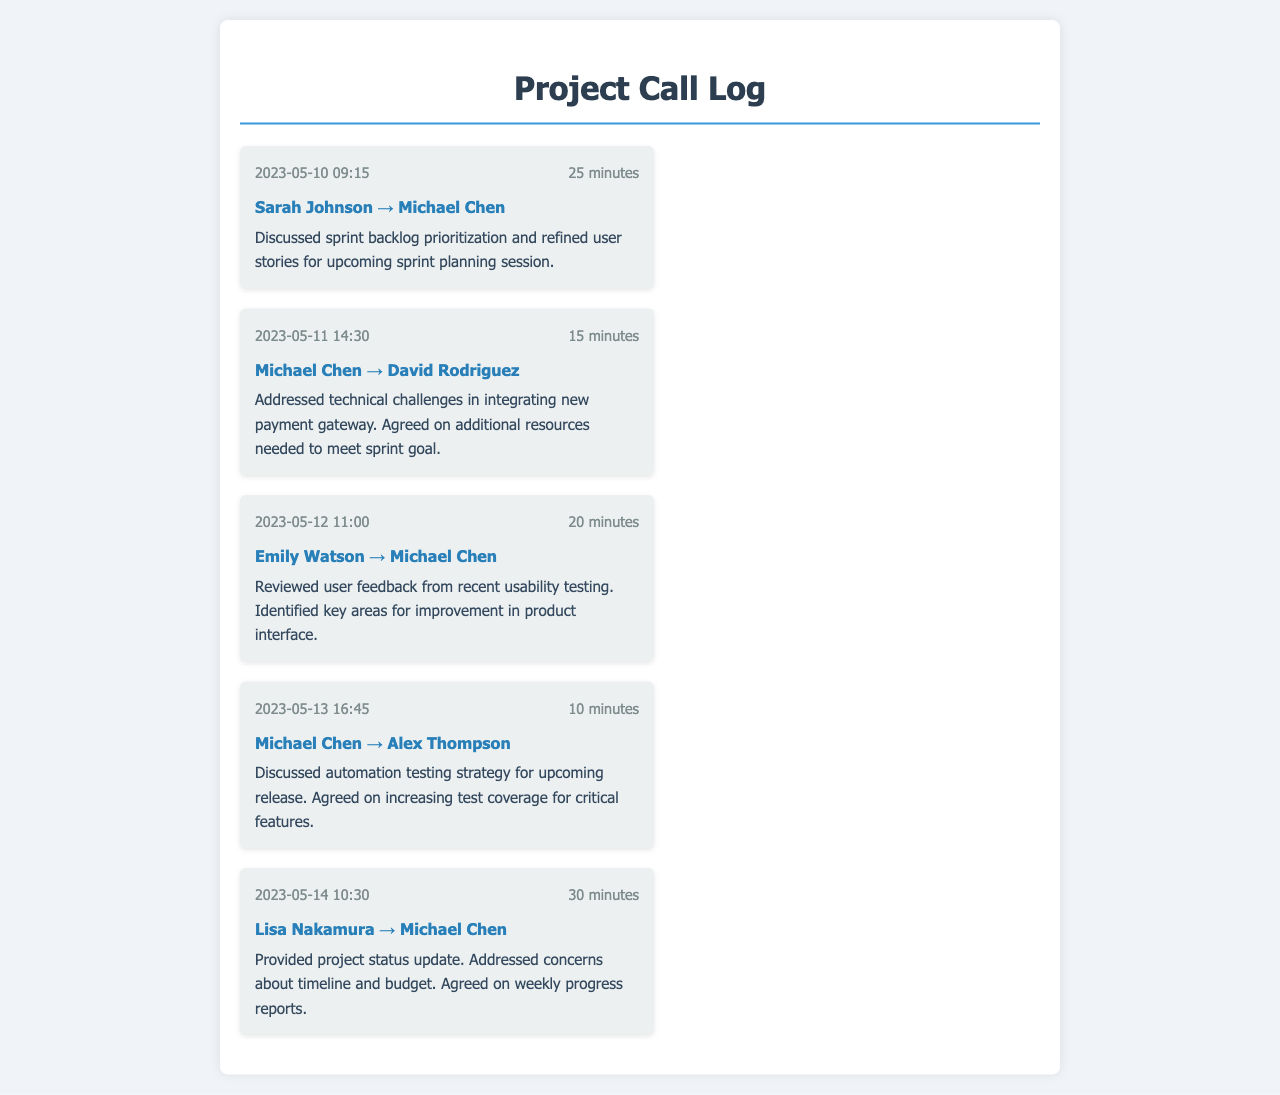what is the date of the first call? The first call in the log occurred on May 10, 2023.
Answer: May 10, 2023 who participated in the call on May 12, 2023? The call on May 12 involved Emily Watson and Michael Chen.
Answer: Emily Watson, Michael Chen how long was the call on May 11, 2023? The duration of the call on May 11, 2023, was 15 minutes.
Answer: 15 minutes what was discussed in the call on May 14, 2023? The call on May 14 involved a project status update, timeline, and budget concerns.
Answer: Project status update, timeline, budget how many minutes did the call on May 13, 2023, last? The call on May 13 lasted for 10 minutes.
Answer: 10 minutes who was the primary participant in all the calls? Michael Chen participated in all the calls listed in the log.
Answer: Michael Chen what was a key point discussed in the May 10, 2023 call? The key point discussed was sprint backlog prioritization and refinement of user stories.
Answer: Sprint backlog prioritization, refined user stories how many calls are recorded in total? There are five calls recorded in the document.
Answer: Five calls 